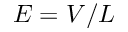<formula> <loc_0><loc_0><loc_500><loc_500>E = V / L</formula> 